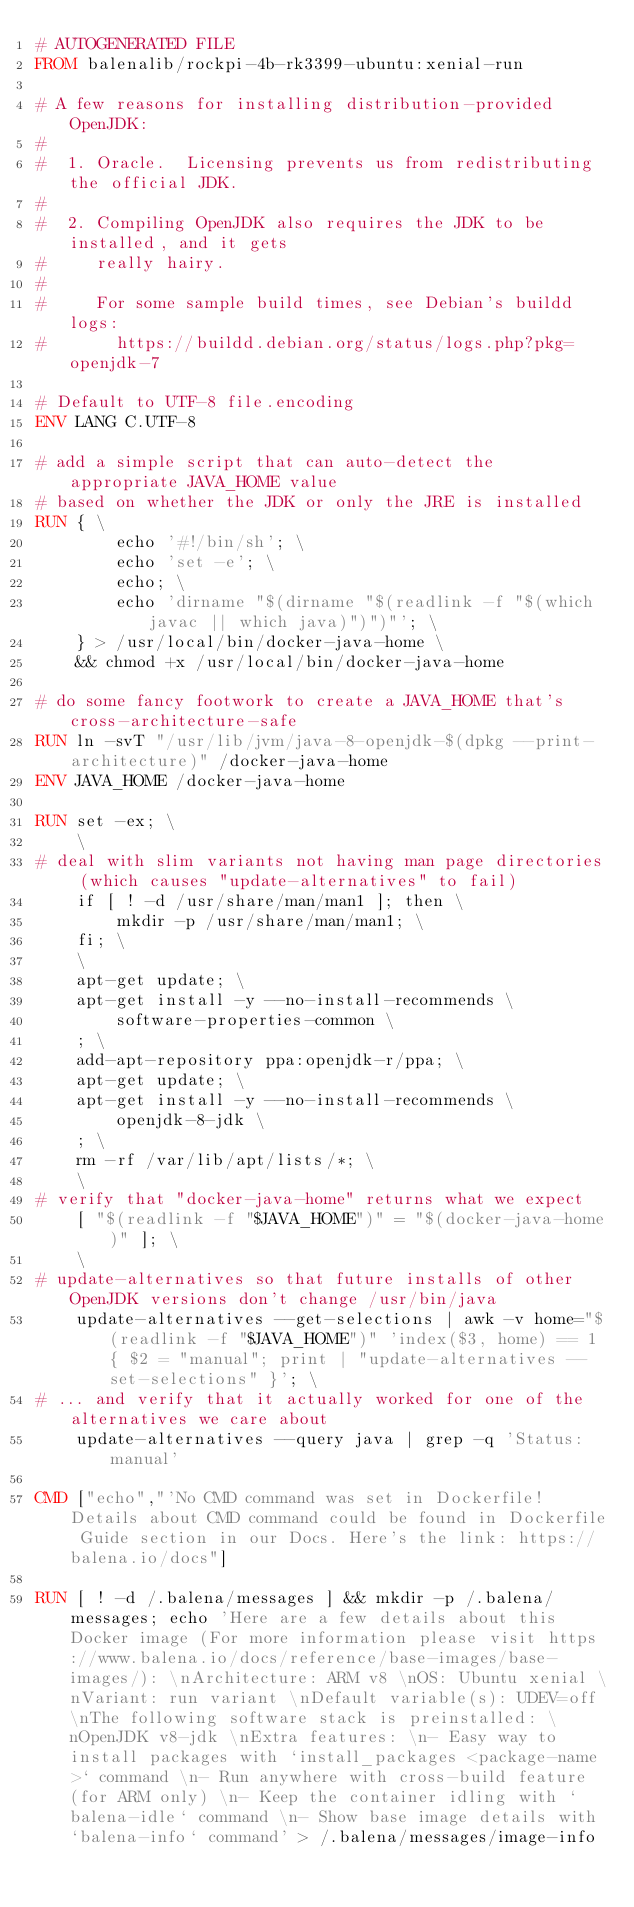<code> <loc_0><loc_0><loc_500><loc_500><_Dockerfile_># AUTOGENERATED FILE
FROM balenalib/rockpi-4b-rk3399-ubuntu:xenial-run

# A few reasons for installing distribution-provided OpenJDK:
#
#  1. Oracle.  Licensing prevents us from redistributing the official JDK.
#
#  2. Compiling OpenJDK also requires the JDK to be installed, and it gets
#     really hairy.
#
#     For some sample build times, see Debian's buildd logs:
#       https://buildd.debian.org/status/logs.php?pkg=openjdk-7

# Default to UTF-8 file.encoding
ENV LANG C.UTF-8

# add a simple script that can auto-detect the appropriate JAVA_HOME value
# based on whether the JDK or only the JRE is installed
RUN { \
		echo '#!/bin/sh'; \
		echo 'set -e'; \
		echo; \
		echo 'dirname "$(dirname "$(readlink -f "$(which javac || which java)")")"'; \
	} > /usr/local/bin/docker-java-home \
	&& chmod +x /usr/local/bin/docker-java-home

# do some fancy footwork to create a JAVA_HOME that's cross-architecture-safe
RUN ln -svT "/usr/lib/jvm/java-8-openjdk-$(dpkg --print-architecture)" /docker-java-home
ENV JAVA_HOME /docker-java-home

RUN set -ex; \
	\
# deal with slim variants not having man page directories (which causes "update-alternatives" to fail)
	if [ ! -d /usr/share/man/man1 ]; then \
		mkdir -p /usr/share/man/man1; \
	fi; \
	\
	apt-get update; \
	apt-get install -y --no-install-recommends \
		software-properties-common \
	; \
	add-apt-repository ppa:openjdk-r/ppa; \
	apt-get update; \
	apt-get install -y --no-install-recommends \
		openjdk-8-jdk \
	; \
	rm -rf /var/lib/apt/lists/*; \
	\
# verify that "docker-java-home" returns what we expect
	[ "$(readlink -f "$JAVA_HOME")" = "$(docker-java-home)" ]; \
	\
# update-alternatives so that future installs of other OpenJDK versions don't change /usr/bin/java
	update-alternatives --get-selections | awk -v home="$(readlink -f "$JAVA_HOME")" 'index($3, home) == 1 { $2 = "manual"; print | "update-alternatives --set-selections" }'; \
# ... and verify that it actually worked for one of the alternatives we care about
	update-alternatives --query java | grep -q 'Status: manual'

CMD ["echo","'No CMD command was set in Dockerfile! Details about CMD command could be found in Dockerfile Guide section in our Docs. Here's the link: https://balena.io/docs"]

RUN [ ! -d /.balena/messages ] && mkdir -p /.balena/messages; echo 'Here are a few details about this Docker image (For more information please visit https://www.balena.io/docs/reference/base-images/base-images/): \nArchitecture: ARM v8 \nOS: Ubuntu xenial \nVariant: run variant \nDefault variable(s): UDEV=off \nThe following software stack is preinstalled: \nOpenJDK v8-jdk \nExtra features: \n- Easy way to install packages with `install_packages <package-name>` command \n- Run anywhere with cross-build feature  (for ARM only) \n- Keep the container idling with `balena-idle` command \n- Show base image details with `balena-info` command' > /.balena/messages/image-info</code> 